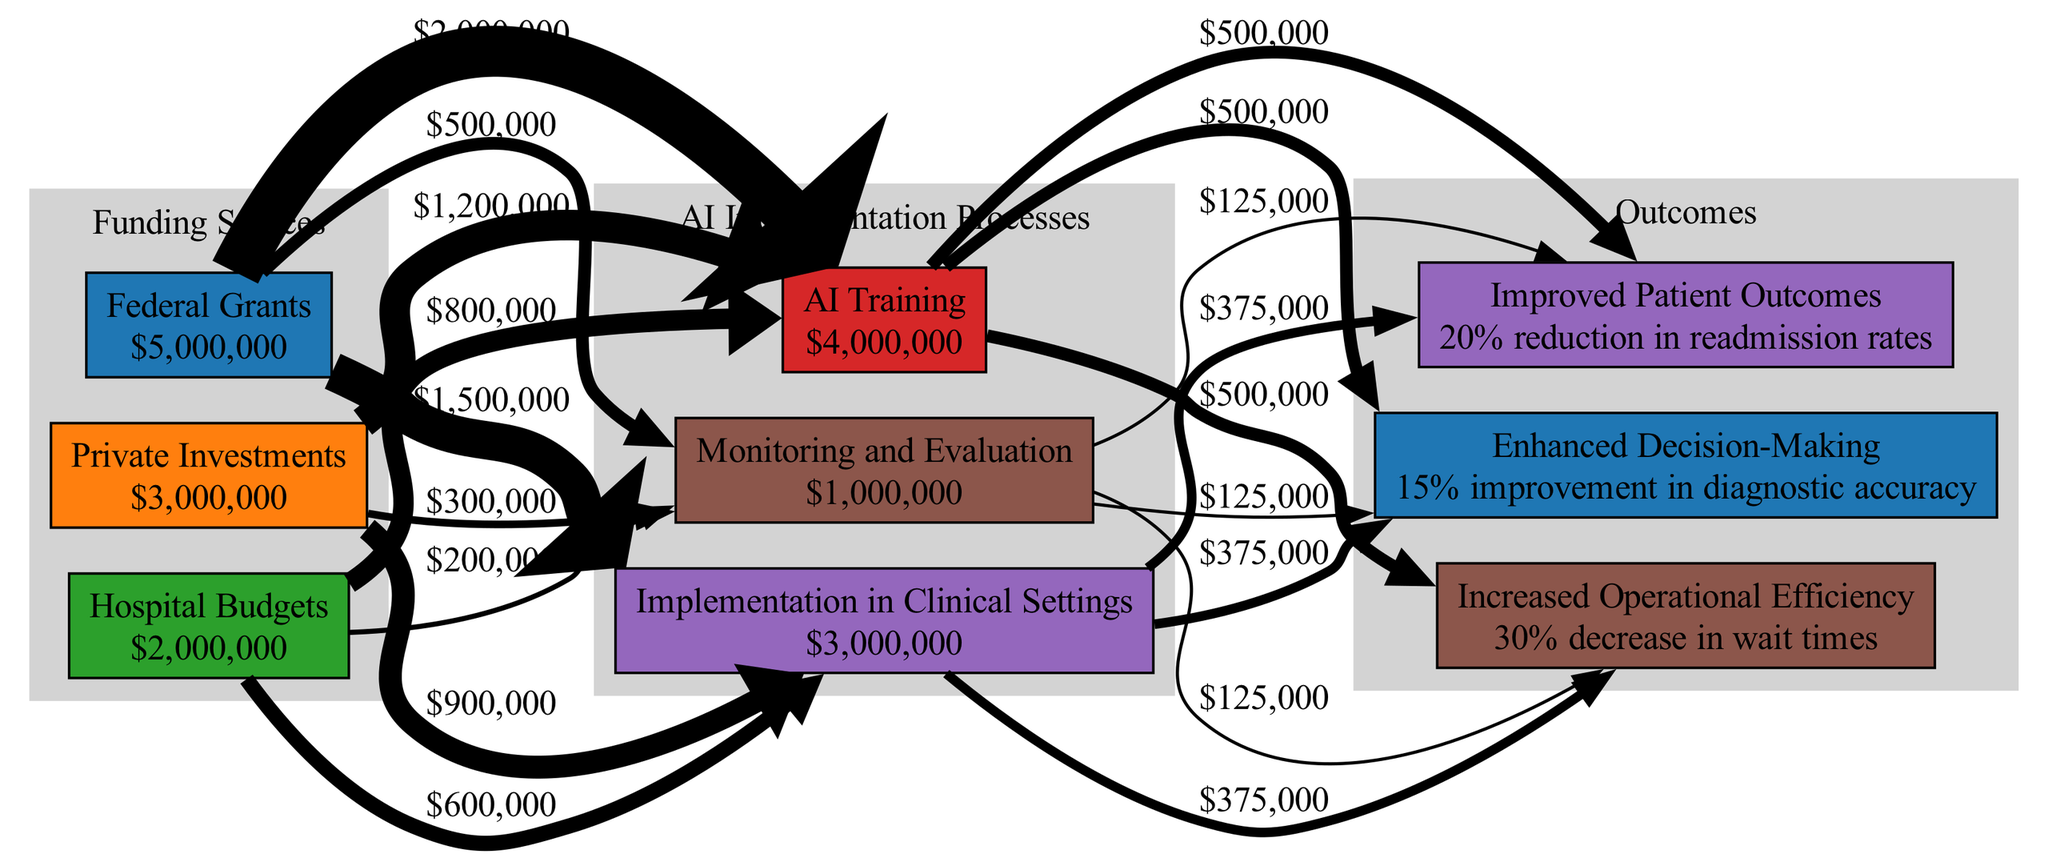What is the total amount of funding from Federal Grants? The diagram states that the amount of funding from Federal Grants is $5,000,000, which is explicitly indicated next to the node representing Federal Grants.
Answer: $5,000,000 How many processes are involved in the AI implementation? The diagram shows three distinct processes labeled within the AI Implementation Processes section, which are AI Training, Implementation in Clinical Settings, and Monitoring and Evaluation.
Answer: 3 What is the cost of the implementation in clinical settings? The implemented cost for Implementation in Clinical Settings is noted in the diagram as $3,000,000, shown next to the corresponding process node.
Answer: $3,000,000 What is the benefit of Improved Patient Outcomes? The diagram specifies that Improved Patient Outcomes correspond to a 20% reduction in readmission rates, which is stated next to the outcome node representing this benefit.
Answer: 20% reduction in readmission rates Which funding source contributes the least? The funding source with the least contribution is Hospital Budgets, which amounts to $2,000,000 as shown in the diagram.
Answer: Hospital Budgets How much total funding is allocated to AI Training? The diagram provides a total of $4,000,000 allocated for AI Training, indicated next to the relevant process node.
Answer: $4,000,000 What is the relationship between Federal Grants and AI Training? Federal Grants directly influences AI Training as indicated by the edge connecting them, showing a weight of $2,500,000, which represents part of the flow from Federal Grants through to AI Training.
Answer: $2,500,000 Which process has the highest cost? The process with the highest cost is AI Training, which is $4,000,000 as labeled in the diagram.
Answer: AI Training How is the outcome Enhanced Decision-Making produced? Enhanced Decision-Making is a result of the AI processes, particularly connected to both AI Training and Implementation in Clinical Settings, receiving a combined weight of $200,000 from these processes as outlined by the edges leading to this outcome node.
Answer: $200,000 